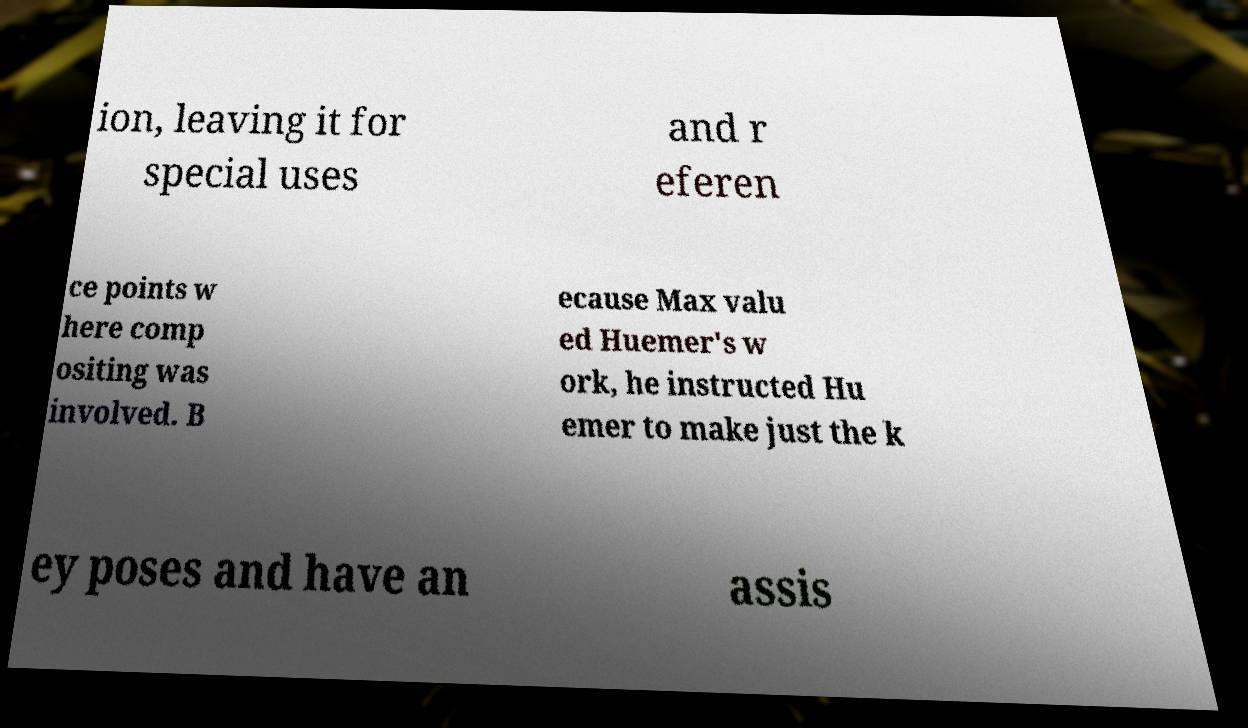Please identify and transcribe the text found in this image. ion, leaving it for special uses and r eferen ce points w here comp ositing was involved. B ecause Max valu ed Huemer's w ork, he instructed Hu emer to make just the k ey poses and have an assis 